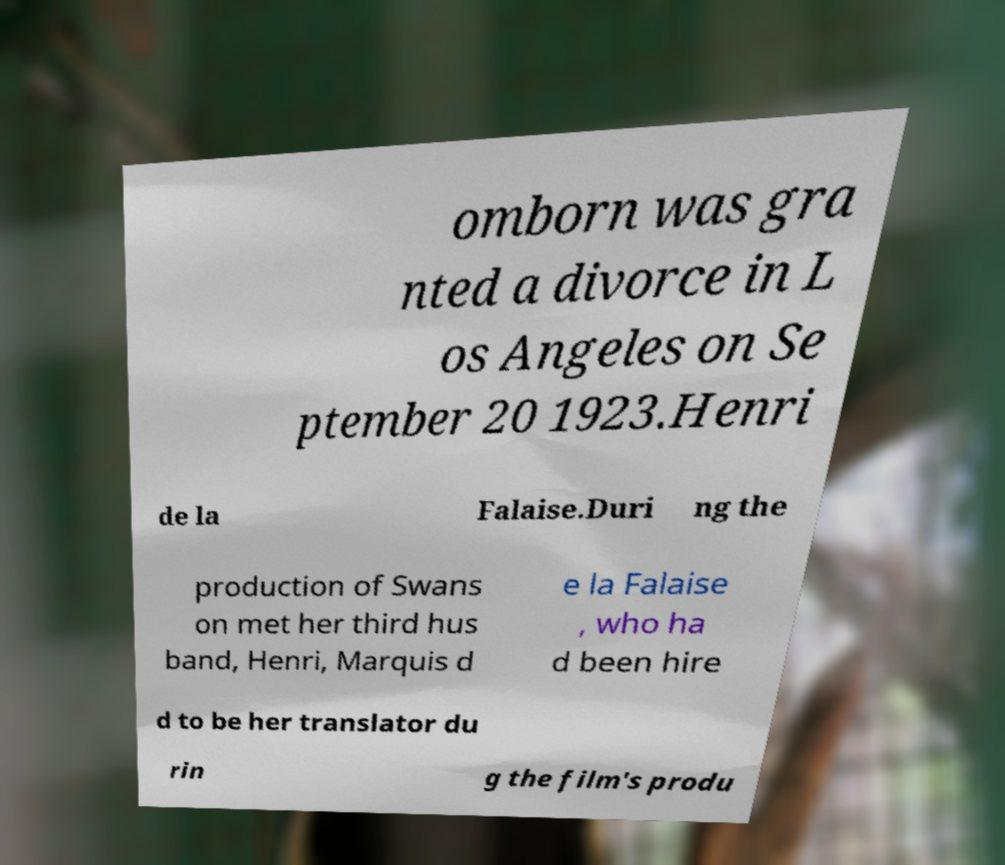Can you accurately transcribe the text from the provided image for me? omborn was gra nted a divorce in L os Angeles on Se ptember 20 1923.Henri de la Falaise.Duri ng the production of Swans on met her third hus band, Henri, Marquis d e la Falaise , who ha d been hire d to be her translator du rin g the film's produ 